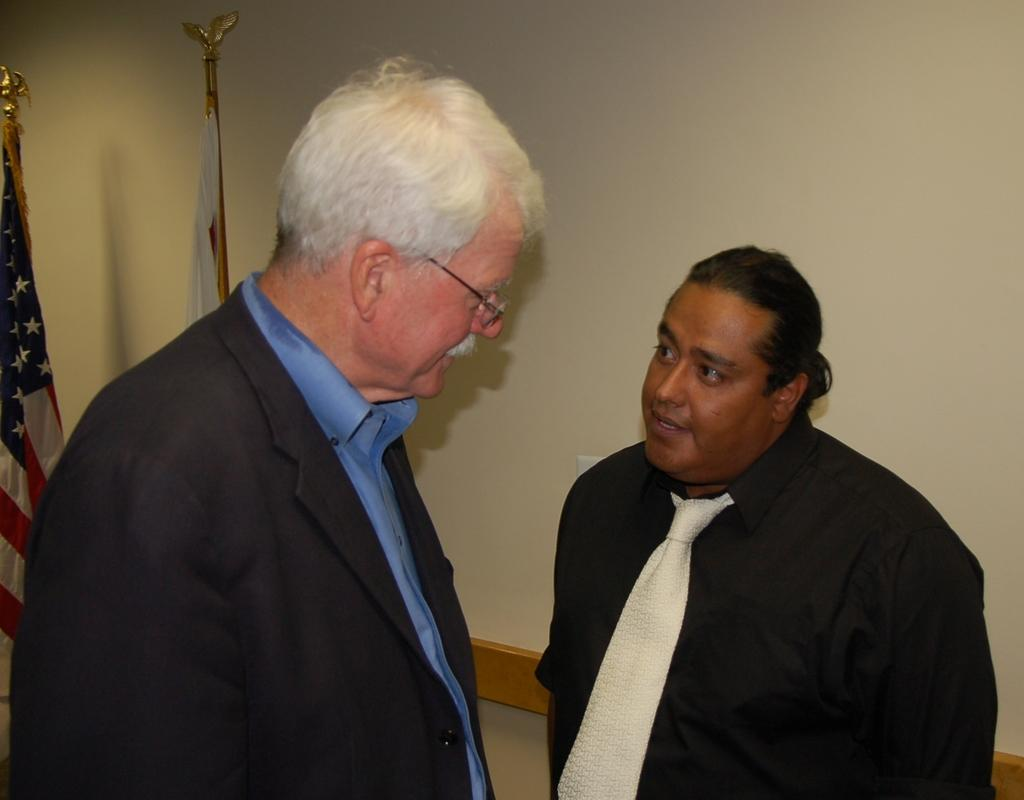What can be seen in the image involving men? There are men standing in the image. What else is visible in the image besides the men? There are two flags and a wall visible in the image. Can you describe the wall in the image? The wall is white in color. What are the men doing in the image? The men are looking at each other. What type of card is being held by the men in the image? There is no card present in the image; the men are simply looking at each other. 